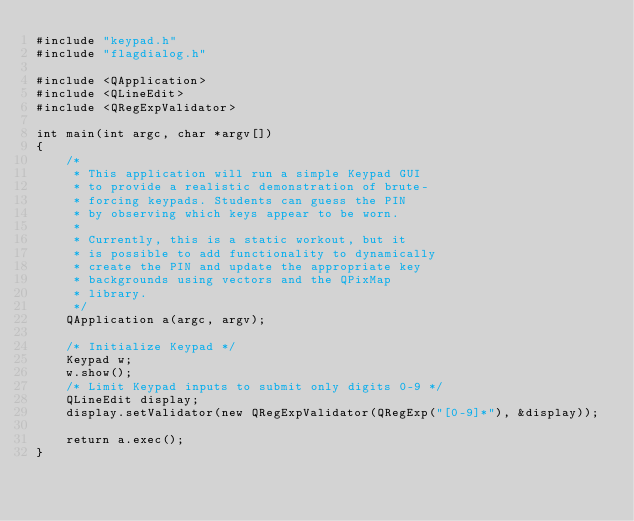Convert code to text. <code><loc_0><loc_0><loc_500><loc_500><_C++_>#include "keypad.h"
#include "flagdialog.h"

#include <QApplication>
#include <QLineEdit>
#include <QRegExpValidator>

int main(int argc, char *argv[])
{
    /*
     * This application will run a simple Keypad GUI
     * to provide a realistic demonstration of brute-
     * forcing keypads. Students can guess the PIN
     * by observing which keys appear to be worn.
     *
     * Currently, this is a static workout, but it
     * is possible to add functionality to dynamically
     * create the PIN and update the appropriate key
     * backgrounds using vectors and the QPixMap
     * library.
     */
    QApplication a(argc, argv);

    /* Initialize Keypad */
    Keypad w;
    w.show();
    /* Limit Keypad inputs to submit only digits 0-9 */
    QLineEdit display;
    display.setValidator(new QRegExpValidator(QRegExp("[0-9]*"), &display));

    return a.exec();
}
</code> 